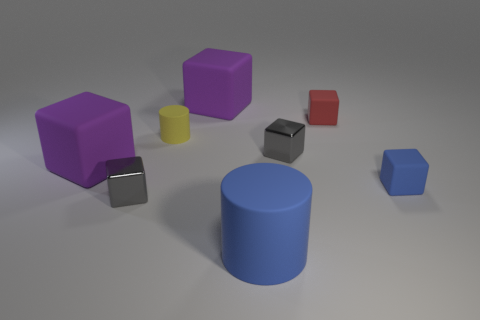Are there any patterns or consistencies in the arrangement of these objects? The objects appear to be randomly placed without any evident pattern in their arrangement. However, there is a mix of geometric shapes including cylinders and cubes that provide a sense of variety.  Based on the shadows, what can you infer about the lighting in this scene? The shadows are soft and extend mainly to one side, which suggests a single diffuse light source positioned to the top left of the scene, casting light diagonally across the objects. 